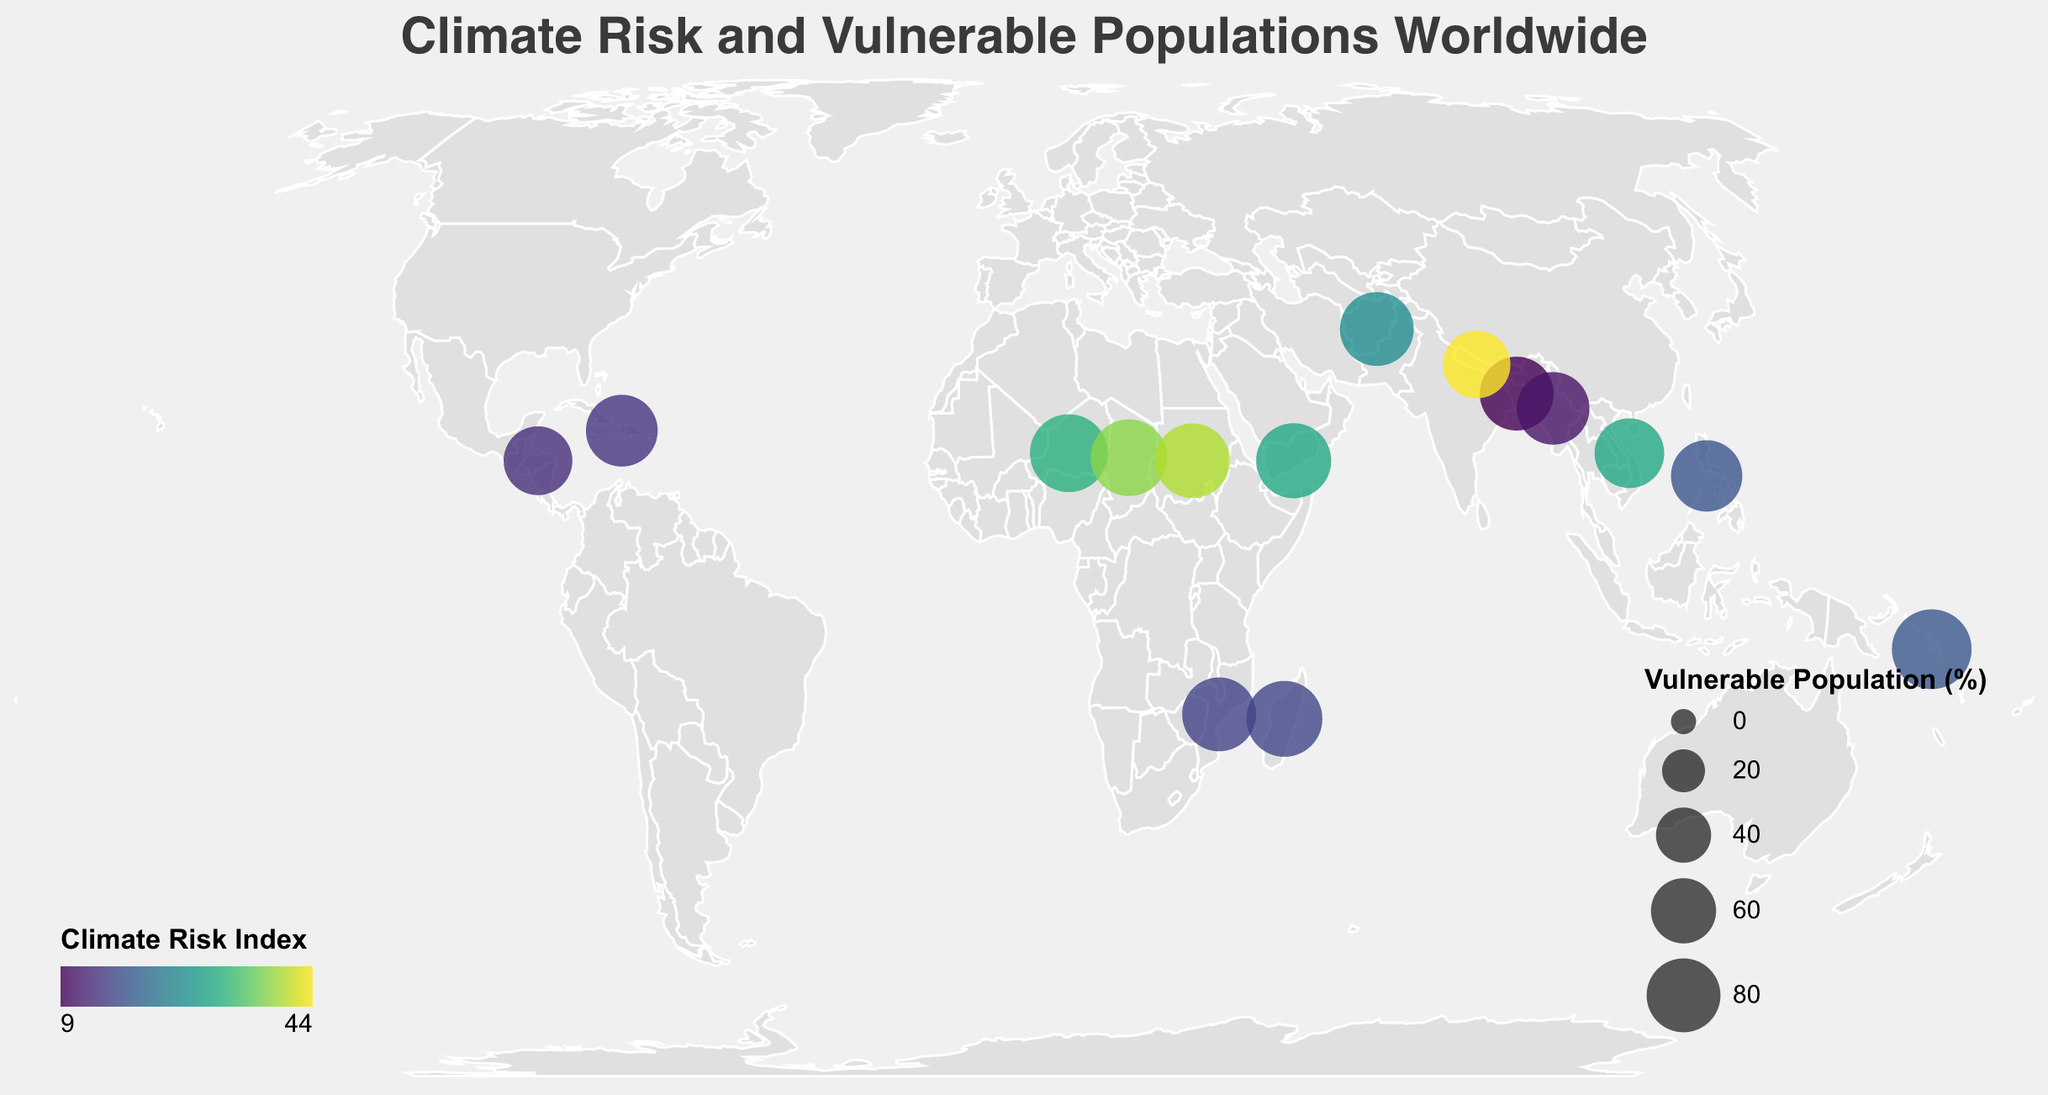What is the title of the figure? The title of the figure is located at the top and is displayed in a larger font size to catch the viewer's attention. It describes what the figure is about.
Answer: Climate Risk and Vulnerable Populations Worldwide Which country has the highest Climate Risk Index? By looking at the color legend, the countries with higher Climate Risk Index will be in the darker colors like deep yellow-green. Identify the darkest colored circle.
Answer: Sudan Which region has the highest percentage of vulnerable populations? Compare the sizes of the circles which represent the percentage of vulnerable populations. The largest circle will indicate the highest percentage.
Answer: Solomon Islands How many countries are shown in the figure? Count the number of circles on the geographic plot as each circle represents a different country.
Answer: 15 Which country in Southeast Asia has the highest Climate Risk Index? Identify the circle in Southeast Asia region and compare their color intensity with reference to the Climate Risk Index legend. The darkest colored circle indicates the highest index.
Answer: Vietnam Which country faces the threat of glacial lake outburst floods? Look for the tooltip information that identifies the Key Environmental Threat for each circle when the cursor hovers over it.
Answer: Nepal Compare the percentages of vulnerable populations in Chad and Yemen. Which is higher, and by how much? Identify the circles for Chad and Yemen, note their reported percentages of vulnerable populations, and calculate the difference.
Answer: Chad by 4% Which key environmental threat is shared between Bangladesh and Solomon Islands? Examine the tooltip information for Key Environmental Threat for both countries and identify any shared threats.
Answer: Sea level rise Which country in the figure is experiencing the combined threats of extreme heat and desertification? Find the tooltip for each country and look for the specific Key Environmental Threat for extreme heat and desertification.
Answer: Niger Order the countries in Central and Southeast Asia by their Climate Risk Index from highest to lowest. Identify the countries in the specified regions, note their Climate Risk Index, and then sort them in descending order.
Answer: Afghanistan, Vietnam, Philippines, Myanmar, Bangladesh 